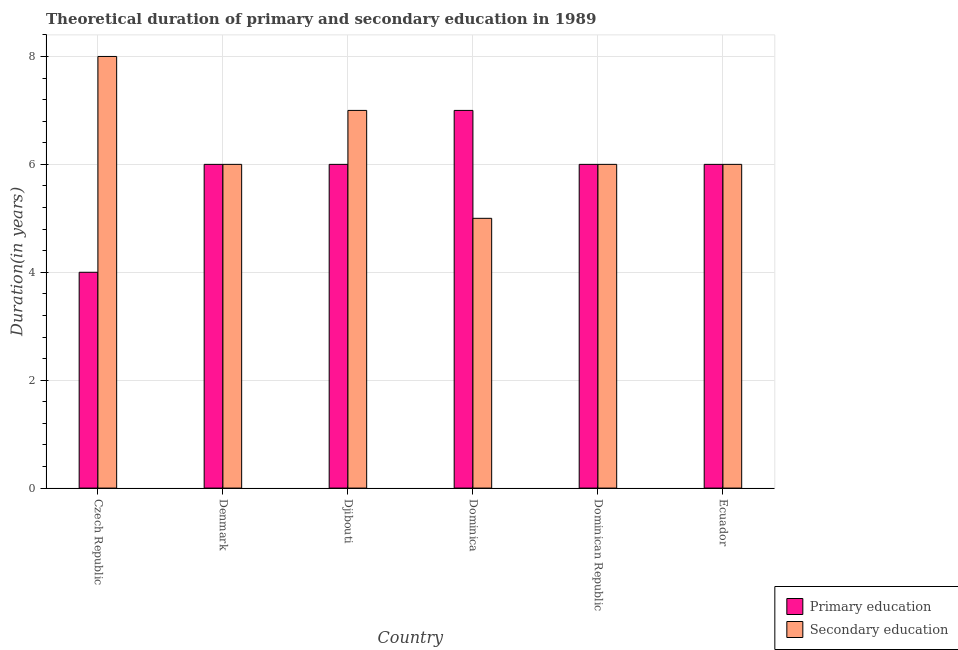How many different coloured bars are there?
Make the answer very short. 2. How many groups of bars are there?
Offer a terse response. 6. Are the number of bars on each tick of the X-axis equal?
Keep it short and to the point. Yes. How many bars are there on the 2nd tick from the right?
Your answer should be compact. 2. What is the label of the 6th group of bars from the left?
Ensure brevity in your answer.  Ecuador. In how many cases, is the number of bars for a given country not equal to the number of legend labels?
Offer a terse response. 0. Across all countries, what is the maximum duration of primary education?
Give a very brief answer. 7. Across all countries, what is the minimum duration of primary education?
Offer a terse response. 4. In which country was the duration of secondary education maximum?
Give a very brief answer. Czech Republic. In which country was the duration of secondary education minimum?
Your response must be concise. Dominica. What is the total duration of primary education in the graph?
Your answer should be very brief. 35. What is the difference between the duration of secondary education in Djibouti and that in Ecuador?
Your response must be concise. 1. What is the difference between the duration of secondary education in Dominica and the duration of primary education in Dominican Republic?
Your answer should be very brief. -1. What is the average duration of secondary education per country?
Provide a short and direct response. 6.33. In how many countries, is the duration of primary education greater than 5.2 years?
Offer a terse response. 5. Is the duration of secondary education in Djibouti less than that in Dominica?
Offer a terse response. No. Is the difference between the duration of primary education in Czech Republic and Djibouti greater than the difference between the duration of secondary education in Czech Republic and Djibouti?
Ensure brevity in your answer.  No. What is the difference between the highest and the second highest duration of primary education?
Give a very brief answer. 1. What is the difference between the highest and the lowest duration of primary education?
Provide a short and direct response. 3. In how many countries, is the duration of secondary education greater than the average duration of secondary education taken over all countries?
Give a very brief answer. 2. What does the 2nd bar from the left in Dominica represents?
Your answer should be compact. Secondary education. What does the 1st bar from the right in Dominican Republic represents?
Give a very brief answer. Secondary education. How many bars are there?
Provide a succinct answer. 12. How many countries are there in the graph?
Offer a very short reply. 6. Does the graph contain any zero values?
Offer a very short reply. No. Does the graph contain grids?
Make the answer very short. Yes. Where does the legend appear in the graph?
Give a very brief answer. Bottom right. How many legend labels are there?
Give a very brief answer. 2. What is the title of the graph?
Give a very brief answer. Theoretical duration of primary and secondary education in 1989. Does "Urban" appear as one of the legend labels in the graph?
Give a very brief answer. No. What is the label or title of the Y-axis?
Your answer should be compact. Duration(in years). What is the Duration(in years) of Primary education in Czech Republic?
Provide a short and direct response. 4. What is the Duration(in years) in Primary education in Dominica?
Give a very brief answer. 7. What is the Duration(in years) in Secondary education in Dominica?
Offer a very short reply. 5. What is the Duration(in years) of Primary education in Dominican Republic?
Your answer should be very brief. 6. What is the Duration(in years) in Secondary education in Dominican Republic?
Your response must be concise. 6. Across all countries, what is the maximum Duration(in years) in Secondary education?
Your answer should be very brief. 8. Across all countries, what is the minimum Duration(in years) of Primary education?
Offer a very short reply. 4. What is the total Duration(in years) of Primary education in the graph?
Keep it short and to the point. 35. What is the difference between the Duration(in years) of Secondary education in Czech Republic and that in Djibouti?
Your response must be concise. 1. What is the difference between the Duration(in years) of Primary education in Czech Republic and that in Ecuador?
Your response must be concise. -2. What is the difference between the Duration(in years) in Secondary education in Czech Republic and that in Ecuador?
Your response must be concise. 2. What is the difference between the Duration(in years) of Secondary education in Denmark and that in Djibouti?
Make the answer very short. -1. What is the difference between the Duration(in years) of Secondary education in Denmark and that in Dominican Republic?
Give a very brief answer. 0. What is the difference between the Duration(in years) in Secondary education in Denmark and that in Ecuador?
Ensure brevity in your answer.  0. What is the difference between the Duration(in years) of Primary education in Djibouti and that in Dominica?
Provide a succinct answer. -1. What is the difference between the Duration(in years) in Secondary education in Djibouti and that in Dominican Republic?
Keep it short and to the point. 1. What is the difference between the Duration(in years) in Primary education in Djibouti and that in Ecuador?
Ensure brevity in your answer.  0. What is the difference between the Duration(in years) of Secondary education in Djibouti and that in Ecuador?
Offer a terse response. 1. What is the difference between the Duration(in years) in Primary education in Dominica and that in Dominican Republic?
Offer a terse response. 1. What is the difference between the Duration(in years) in Secondary education in Dominica and that in Dominican Republic?
Provide a succinct answer. -1. What is the difference between the Duration(in years) of Secondary education in Dominica and that in Ecuador?
Provide a succinct answer. -1. What is the difference between the Duration(in years) of Primary education in Dominican Republic and that in Ecuador?
Your answer should be compact. 0. What is the difference between the Duration(in years) in Secondary education in Dominican Republic and that in Ecuador?
Keep it short and to the point. 0. What is the difference between the Duration(in years) of Primary education in Czech Republic and the Duration(in years) of Secondary education in Djibouti?
Offer a very short reply. -3. What is the difference between the Duration(in years) in Primary education in Czech Republic and the Duration(in years) in Secondary education in Dominican Republic?
Your response must be concise. -2. What is the difference between the Duration(in years) in Primary education in Czech Republic and the Duration(in years) in Secondary education in Ecuador?
Offer a terse response. -2. What is the difference between the Duration(in years) in Primary education in Denmark and the Duration(in years) in Secondary education in Dominica?
Offer a very short reply. 1. What is the difference between the Duration(in years) in Primary education in Djibouti and the Duration(in years) in Secondary education in Dominica?
Ensure brevity in your answer.  1. What is the difference between the Duration(in years) of Primary education in Djibouti and the Duration(in years) of Secondary education in Dominican Republic?
Make the answer very short. 0. What is the difference between the Duration(in years) of Primary education in Dominica and the Duration(in years) of Secondary education in Ecuador?
Your response must be concise. 1. What is the difference between the Duration(in years) in Primary education in Dominican Republic and the Duration(in years) in Secondary education in Ecuador?
Offer a very short reply. 0. What is the average Duration(in years) in Primary education per country?
Keep it short and to the point. 5.83. What is the average Duration(in years) in Secondary education per country?
Ensure brevity in your answer.  6.33. What is the difference between the Duration(in years) of Primary education and Duration(in years) of Secondary education in Czech Republic?
Give a very brief answer. -4. What is the difference between the Duration(in years) of Primary education and Duration(in years) of Secondary education in Dominica?
Your answer should be compact. 2. What is the difference between the Duration(in years) of Primary education and Duration(in years) of Secondary education in Dominican Republic?
Your response must be concise. 0. What is the difference between the Duration(in years) in Primary education and Duration(in years) in Secondary education in Ecuador?
Your answer should be very brief. 0. What is the ratio of the Duration(in years) in Secondary education in Czech Republic to that in Denmark?
Your answer should be compact. 1.33. What is the ratio of the Duration(in years) in Primary education in Czech Republic to that in Djibouti?
Your response must be concise. 0.67. What is the ratio of the Duration(in years) of Secondary education in Czech Republic to that in Djibouti?
Keep it short and to the point. 1.14. What is the ratio of the Duration(in years) of Primary education in Czech Republic to that in Dominica?
Make the answer very short. 0.57. What is the ratio of the Duration(in years) of Secondary education in Czech Republic to that in Dominica?
Provide a short and direct response. 1.6. What is the ratio of the Duration(in years) in Primary education in Czech Republic to that in Ecuador?
Offer a terse response. 0.67. What is the ratio of the Duration(in years) of Secondary education in Denmark to that in Dominica?
Keep it short and to the point. 1.2. What is the ratio of the Duration(in years) in Secondary education in Denmark to that in Ecuador?
Make the answer very short. 1. What is the ratio of the Duration(in years) of Primary education in Djibouti to that in Dominica?
Give a very brief answer. 0.86. What is the ratio of the Duration(in years) in Secondary education in Djibouti to that in Dominica?
Your response must be concise. 1.4. What is the ratio of the Duration(in years) in Primary education in Djibouti to that in Dominican Republic?
Your answer should be very brief. 1. What is the ratio of the Duration(in years) of Secondary education in Djibouti to that in Dominican Republic?
Offer a terse response. 1.17. What is the ratio of the Duration(in years) of Primary education in Dominica to that in Dominican Republic?
Make the answer very short. 1.17. What is the ratio of the Duration(in years) of Primary education in Dominican Republic to that in Ecuador?
Give a very brief answer. 1. What is the ratio of the Duration(in years) in Secondary education in Dominican Republic to that in Ecuador?
Ensure brevity in your answer.  1. What is the difference between the highest and the second highest Duration(in years) in Primary education?
Keep it short and to the point. 1. What is the difference between the highest and the second highest Duration(in years) of Secondary education?
Offer a very short reply. 1. What is the difference between the highest and the lowest Duration(in years) in Secondary education?
Give a very brief answer. 3. 